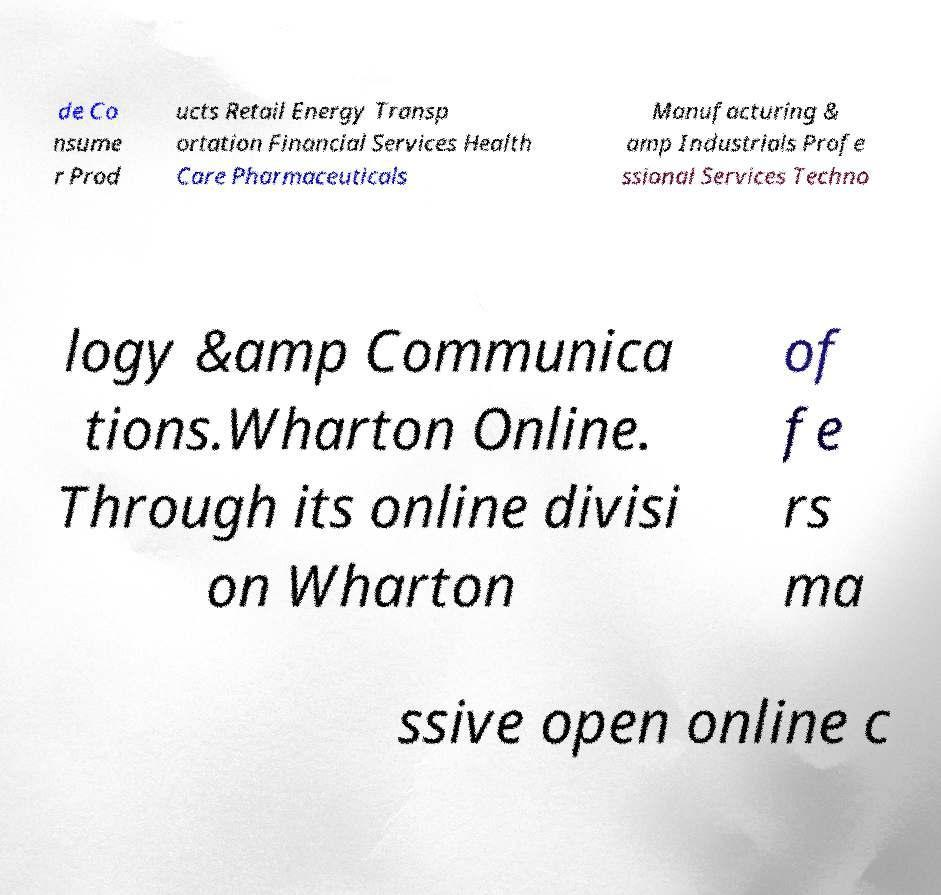There's text embedded in this image that I need extracted. Can you transcribe it verbatim? de Co nsume r Prod ucts Retail Energy Transp ortation Financial Services Health Care Pharmaceuticals Manufacturing & amp Industrials Profe ssional Services Techno logy &amp Communica tions.Wharton Online. Through its online divisi on Wharton of fe rs ma ssive open online c 